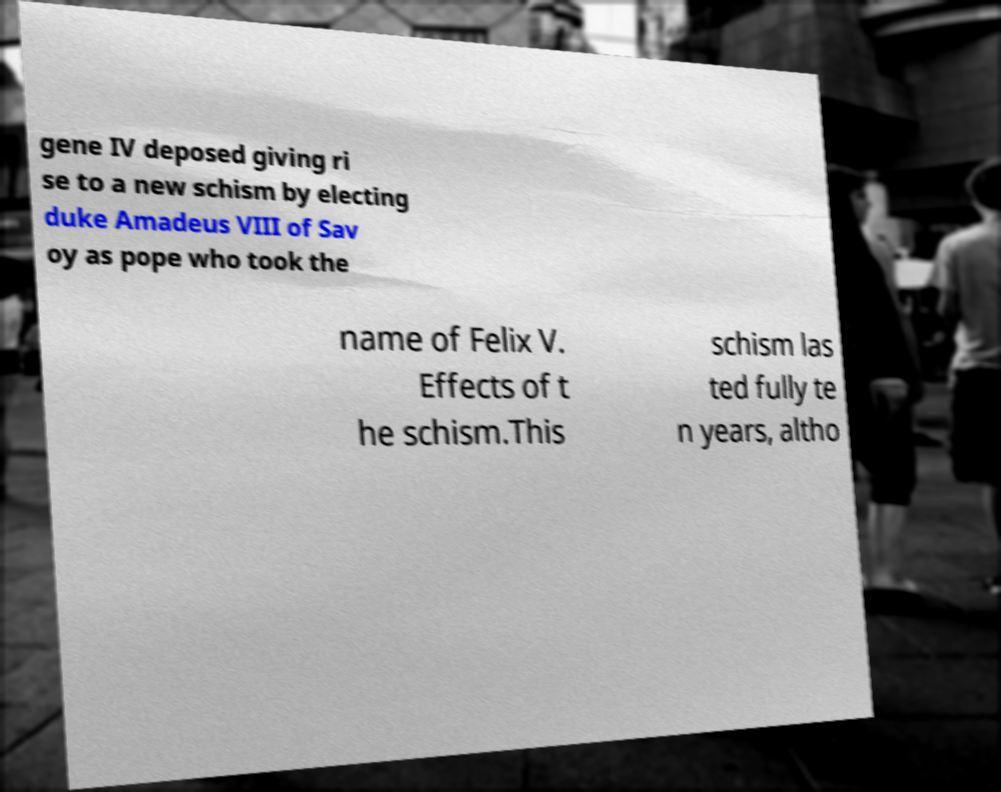I need the written content from this picture converted into text. Can you do that? gene IV deposed giving ri se to a new schism by electing duke Amadeus VIII of Sav oy as pope who took the name of Felix V. Effects of t he schism.This schism las ted fully te n years, altho 